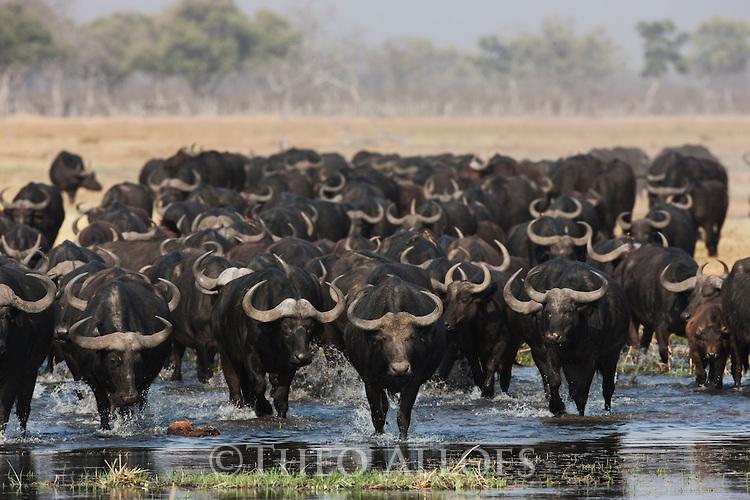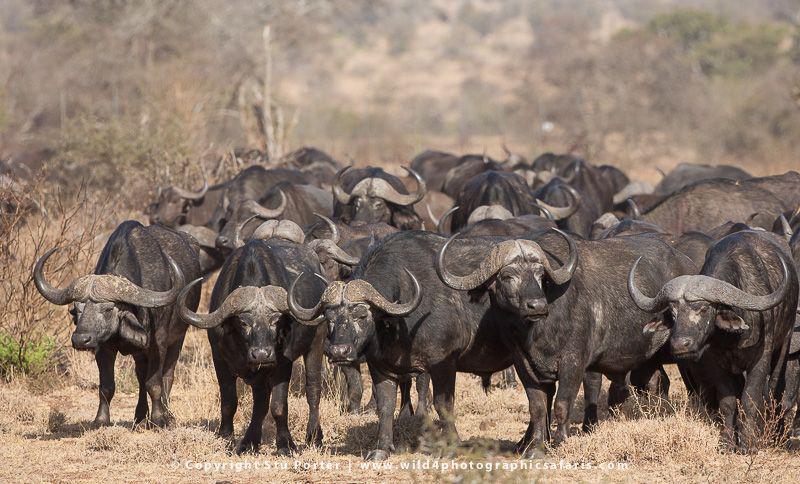The first image is the image on the left, the second image is the image on the right. Examine the images to the left and right. Is the description "In one image, most of the water buffalo stand with their rears turned toward the camera." accurate? Answer yes or no. No. 